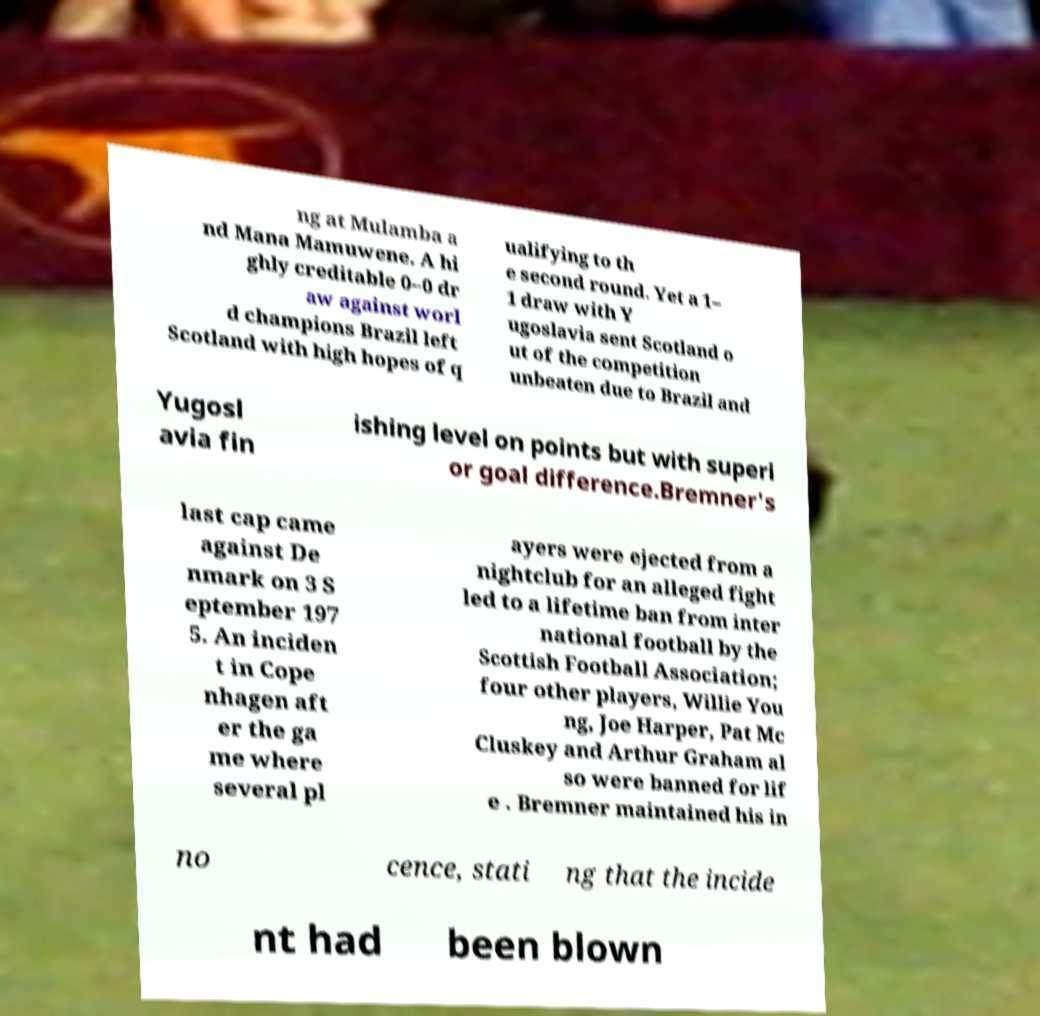Could you extract and type out the text from this image? ng at Mulamba a nd Mana Mamuwene. A hi ghly creditable 0–0 dr aw against worl d champions Brazil left Scotland with high hopes of q ualifying to th e second round. Yet a 1– 1 draw with Y ugoslavia sent Scotland o ut of the competition unbeaten due to Brazil and Yugosl avia fin ishing level on points but with superi or goal difference.Bremner's last cap came against De nmark on 3 S eptember 197 5. An inciden t in Cope nhagen aft er the ga me where several pl ayers were ejected from a nightclub for an alleged fight led to a lifetime ban from inter national football by the Scottish Football Association; four other players, Willie You ng, Joe Harper, Pat Mc Cluskey and Arthur Graham al so were banned for lif e . Bremner maintained his in no cence, stati ng that the incide nt had been blown 